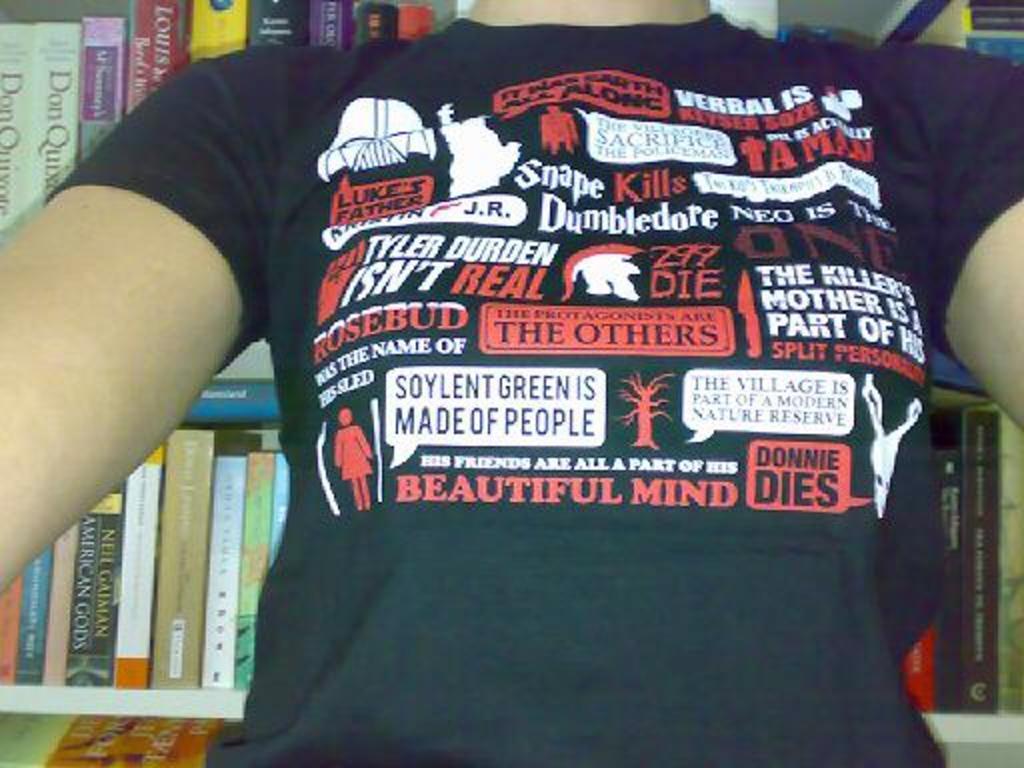Who isn't real?
Offer a terse response. Tyler durden. 